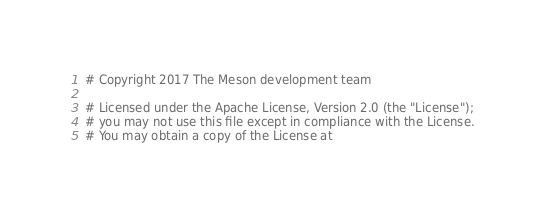Convert code to text. <code><loc_0><loc_0><loc_500><loc_500><_Python_># Copyright 2017 The Meson development team

# Licensed under the Apache License, Version 2.0 (the "License");
# you may not use this file except in compliance with the License.
# You may obtain a copy of the License at
</code> 